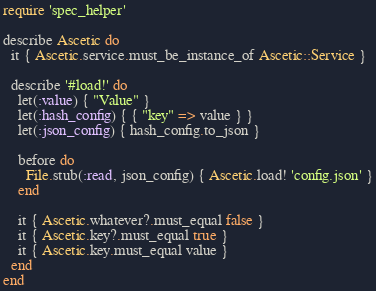<code> <loc_0><loc_0><loc_500><loc_500><_Ruby_>require 'spec_helper'

describe Ascetic do
  it { Ascetic.service.must_be_instance_of Ascetic::Service }

  describe '#load!' do
    let(:value) { "Value" }
    let(:hash_config) { { "key" => value } }
    let(:json_config) { hash_config.to_json }

    before do
      File.stub(:read, json_config) { Ascetic.load! 'config.json' }
    end

    it { Ascetic.whatever?.must_equal false }
    it { Ascetic.key?.must_equal true }
    it { Ascetic.key.must_equal value }
  end
end
</code> 